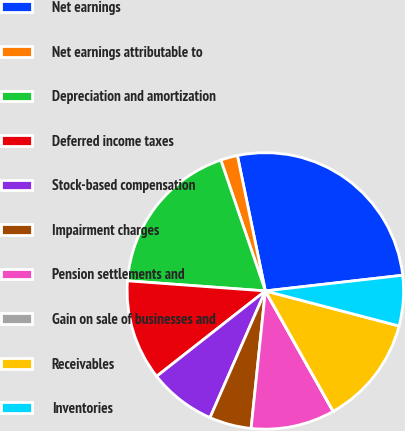<chart> <loc_0><loc_0><loc_500><loc_500><pie_chart><fcel>Net earnings<fcel>Net earnings attributable to<fcel>Depreciation and amortization<fcel>Deferred income taxes<fcel>Stock-based compensation<fcel>Impairment charges<fcel>Pension settlements and<fcel>Gain on sale of businesses and<fcel>Receivables<fcel>Inventories<nl><fcel>26.43%<fcel>1.98%<fcel>18.61%<fcel>11.76%<fcel>7.85%<fcel>4.91%<fcel>9.8%<fcel>0.02%<fcel>12.74%<fcel>5.89%<nl></chart> 